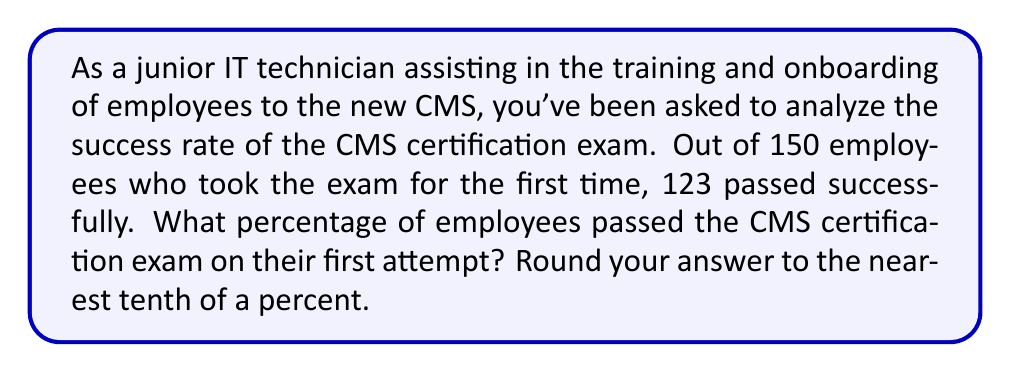Provide a solution to this math problem. To solve this problem, we need to calculate the percentage of employees who passed the exam on their first attempt. Let's break it down step-by-step:

1. Identify the given information:
   - Total number of employees who took the exam: 150
   - Number of employees who passed on the first attempt: 123

2. Calculate the percentage using the formula:
   $$ \text{Percentage} = \frac{\text{Number of successful employees}}{\text{Total number of employees}} \times 100\% $$

3. Plug in the values:
   $$ \text{Percentage} = \frac{123}{150} \times 100\% $$

4. Perform the division:
   $$ \text{Percentage} = 0.82 \times 100\% = 82\% $$

5. Round to the nearest tenth of a percent:
   $82\%$ is already rounded to the nearest tenth, so no further rounding is necessary.

Therefore, 82.0% of employees passed the CMS certification exam on their first attempt.
Answer: 82.0% 